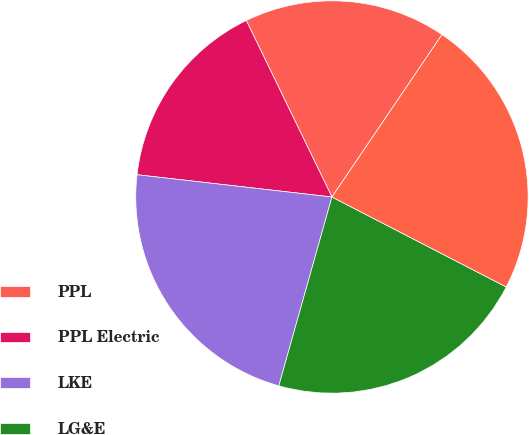Convert chart to OTSL. <chart><loc_0><loc_0><loc_500><loc_500><pie_chart><fcel>PPL<fcel>PPL Electric<fcel>LKE<fcel>LG&E<fcel>KU<nl><fcel>16.67%<fcel>16.0%<fcel>22.45%<fcel>21.78%<fcel>23.11%<nl></chart> 